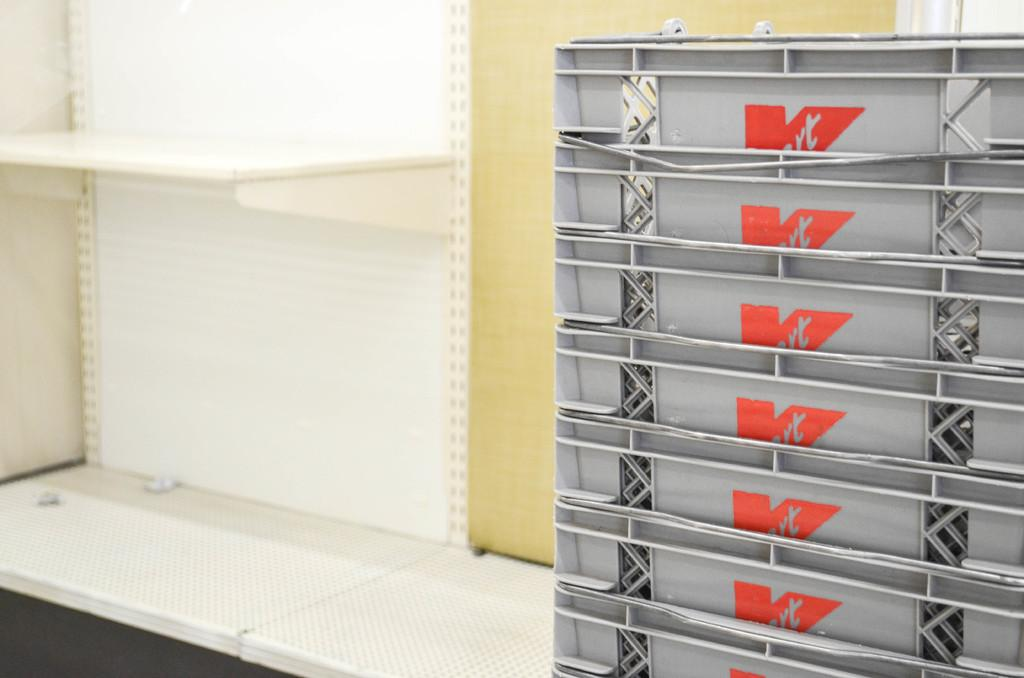<image>
Share a concise interpretation of the image provided. Gray carts that say the letter K on it next to an empty shelf. 